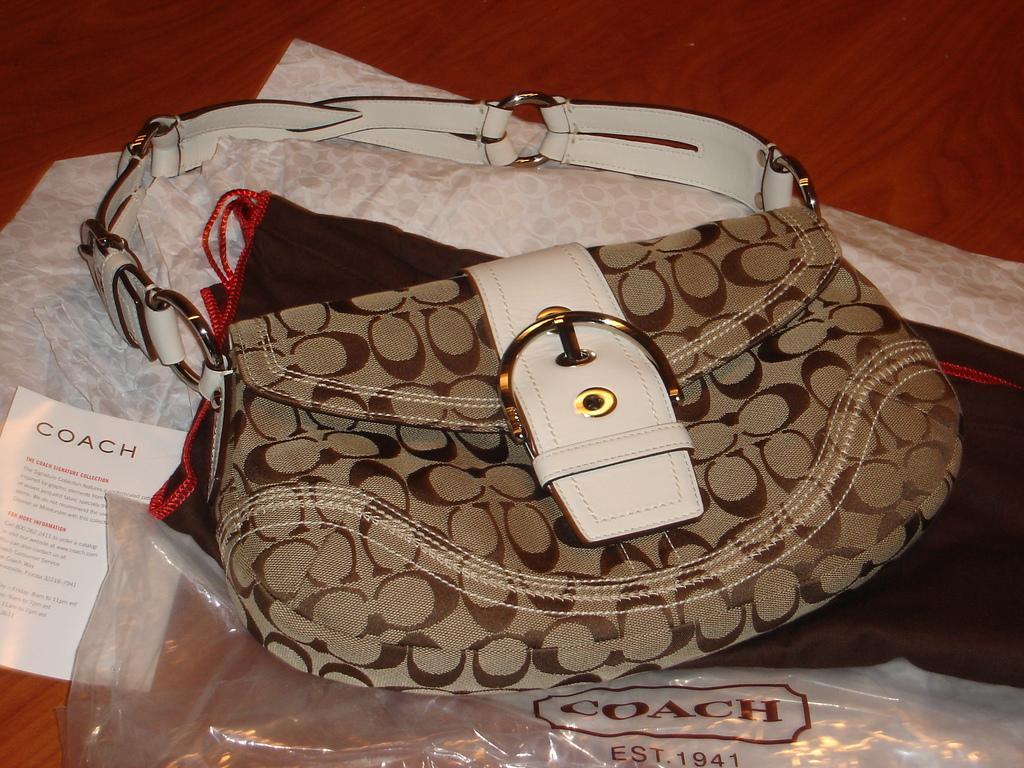How would you summarize this image in a sentence or two? There is a bag on the table. This is paper and there is a cover. 